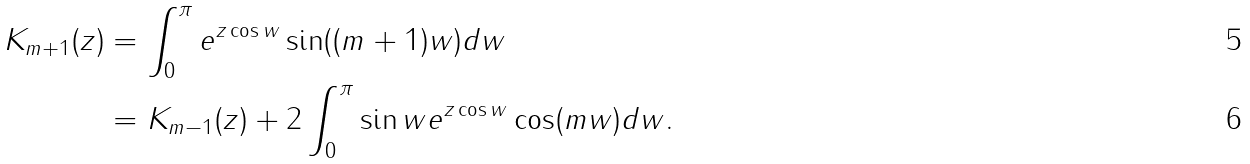<formula> <loc_0><loc_0><loc_500><loc_500>K _ { m + 1 } ( z ) & = \int _ { 0 } ^ { \pi } e ^ { z \cos w } \sin ( ( m + 1 ) w ) d w \\ & = K _ { m - 1 } ( z ) + 2 \int _ { 0 } ^ { \pi } \sin w e ^ { z \cos w } \cos ( m w ) d w .</formula> 